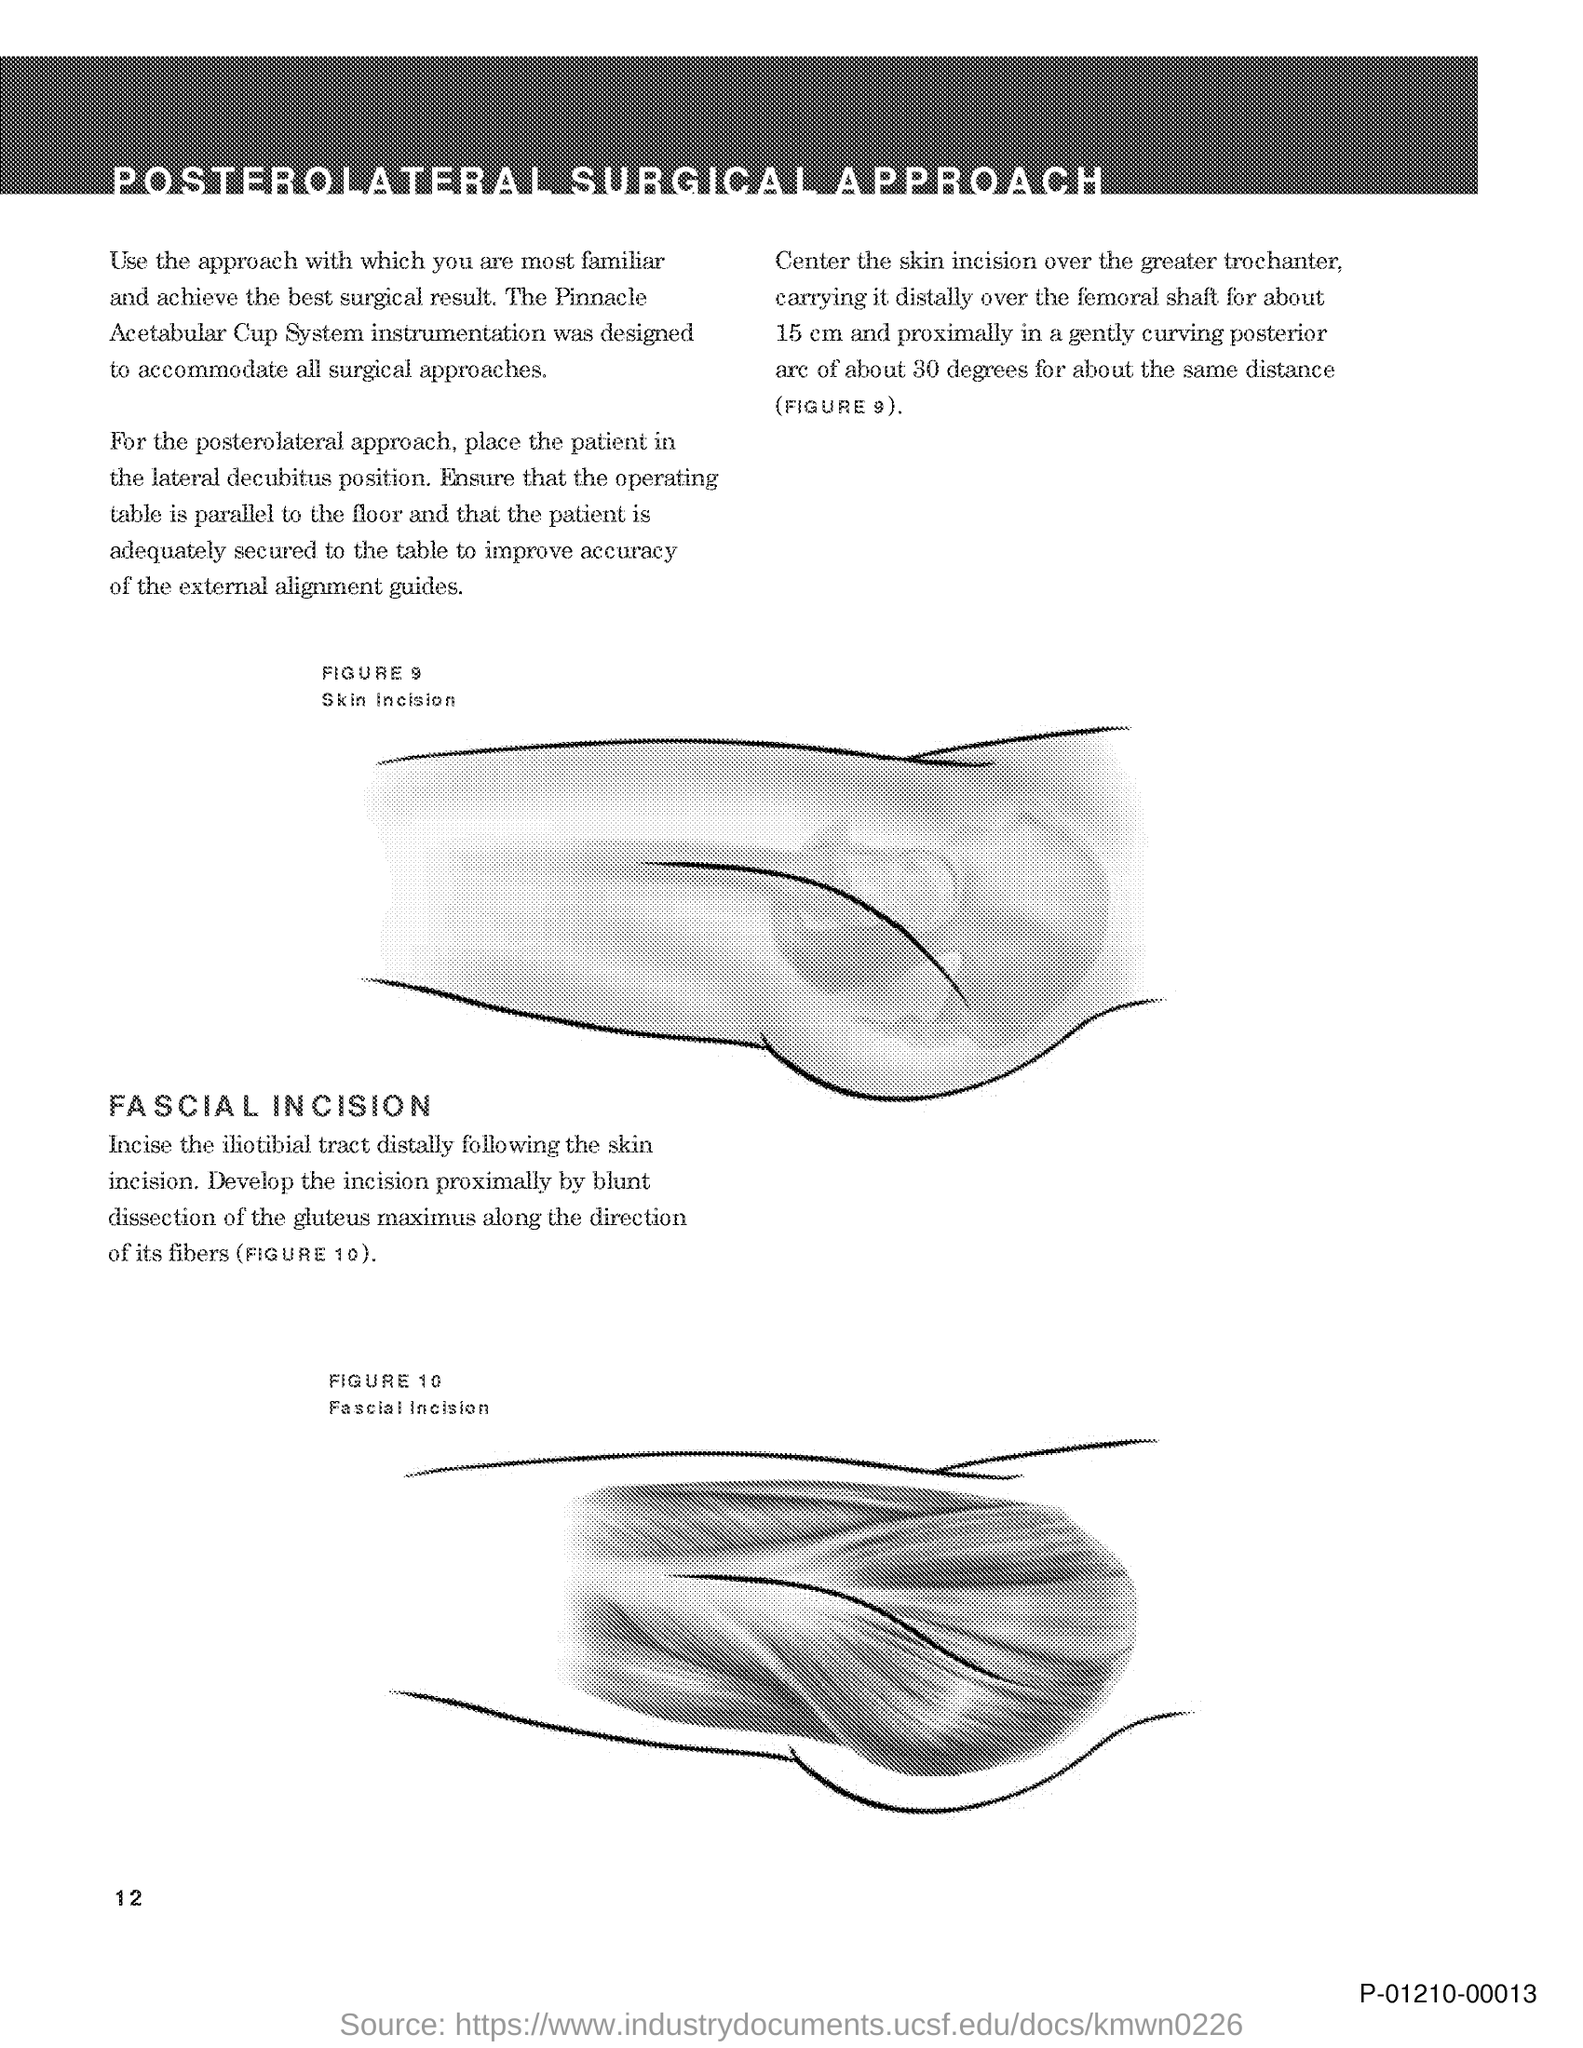Identify some key points in this picture. This document is titled 'Posterolateral Surgical Approach.' The page number is 12. 